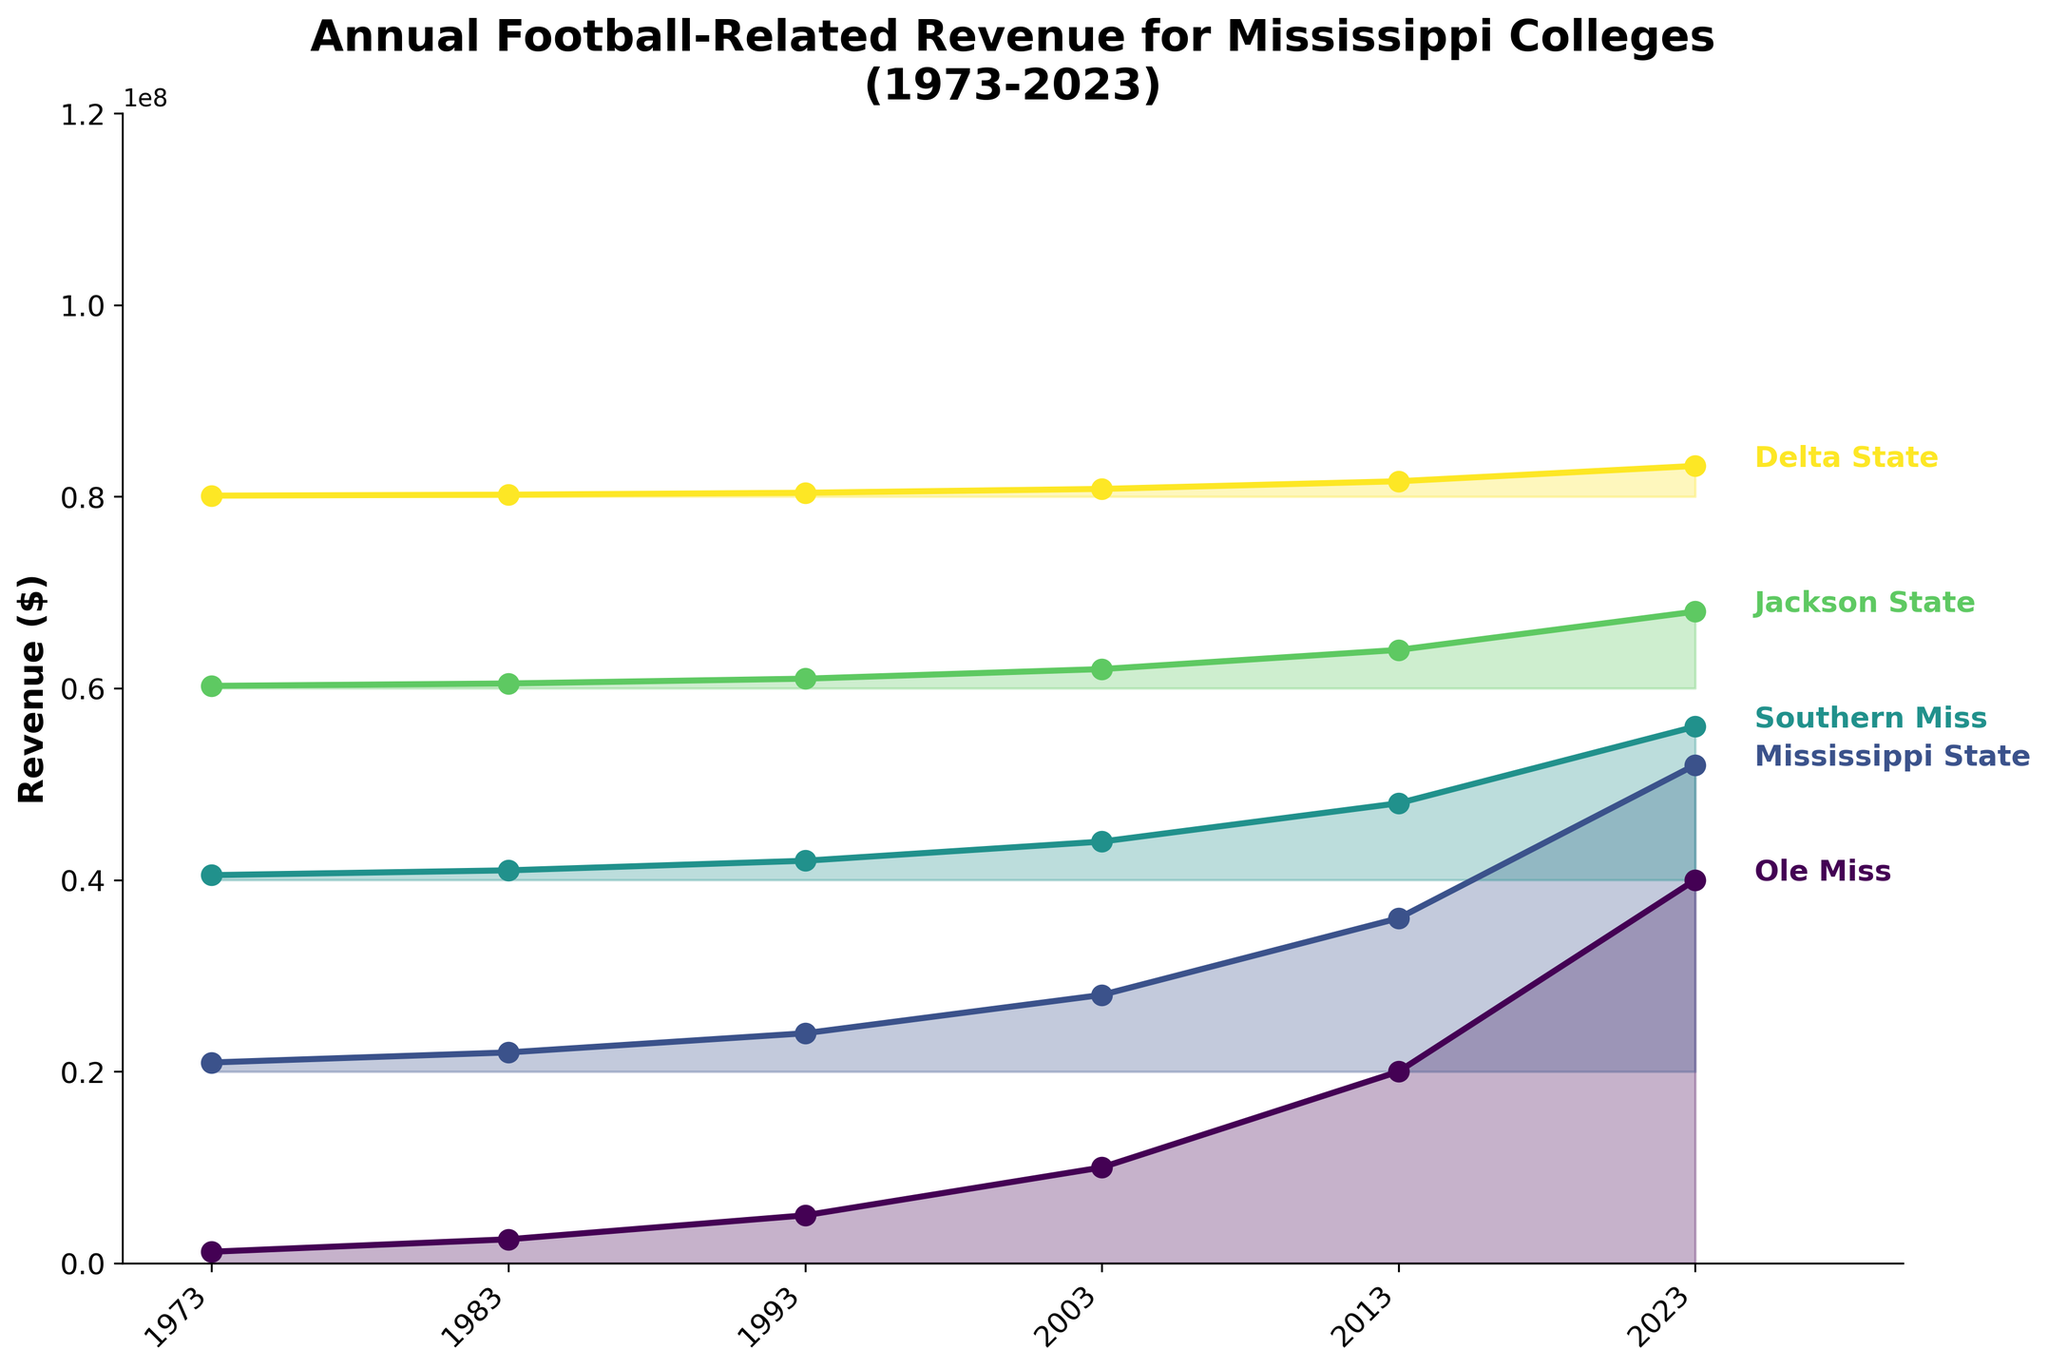what is the title of the figure? The title is located at the top of the figure. It reads "Annual Football-Related Revenue for Mississippi Colleges (1973-2023)."
Answer: Annual Football-Related Revenue for Mississippi Colleges (1973-2023) How many colleges are represented in the plot? There are individual lines and filled areas in the plot, each representing a different college. There are five such distinct lines, indicating five colleges.
Answer: Five Which college had the highest revenue in 2023? By looking at the position of the data points for 2023, Ole Miss has the highest value, positioned at the topmost part in 2023.
Answer: Ole Miss What is the revenue for Southern Miss in the year 1993? Trace the Southern Miss line to the year 1993, where the value reaches up to the corresponding axis. It points at 2000000.
Answer: 2000000 What trend can be observed in the football-related revenues for Mississippi colleges over time? All the lines show a clear upward trend from 1973 to 2023. Each college's revenue has consistently increased over the years.
Answer: Upward trend Which college showed the least amount of revenue growth from 1973 to 2023? By comparing the vertical differences in revenue from 1973 to 2023 for each college, Delta State shows the smallest vertical difference, indicating the least growth.
Answer: Delta State In which decade did Ole Miss see the most significant increase in revenue? By observing the steepness of the slope of Ole Miss's line in each decade, the steepest increase appears between 2013 and 2023.
Answer: 2013-2023 What is the difference in revenue between Ole Miss and Jackson State in the year 2003? The revenue for Ole Miss in 2003 is 10000000, and for Jackson State, it is 2000000. The difference is calculated as 10000000 - 2000000.
Answer: 8000000 Which college had the second-highest revenue in 1983? By comparing the values for the year 1983, Mississippi State has the second-highest revenue, as indicated by the second line from the top for that year.
Answer: Mississippi State How did the revenue for Delta State in 2013 compare to Southern Miss in 1983? Delta State's revenue in 2013 is 1600000, and Southern Miss's in 1983 is 1000000. Delta State's revenue in 2013 is higher.
Answer: Delta State is higher 